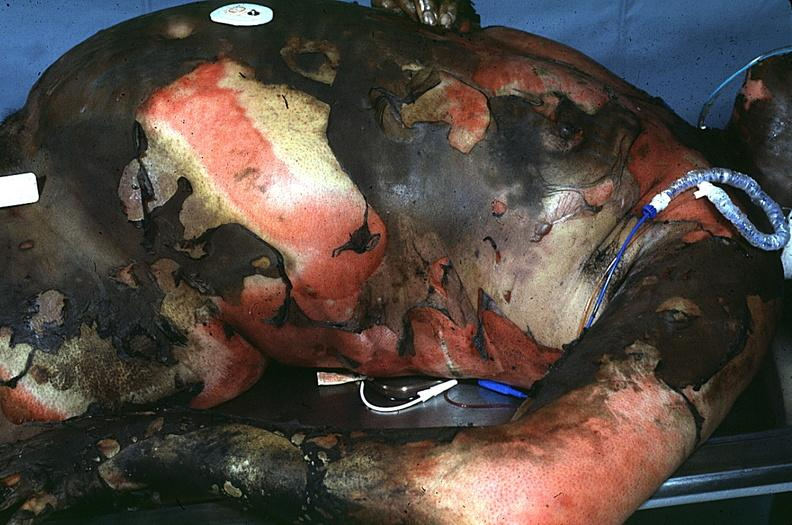do thermal burn?
Answer the question using a single word or phrase. Yes 